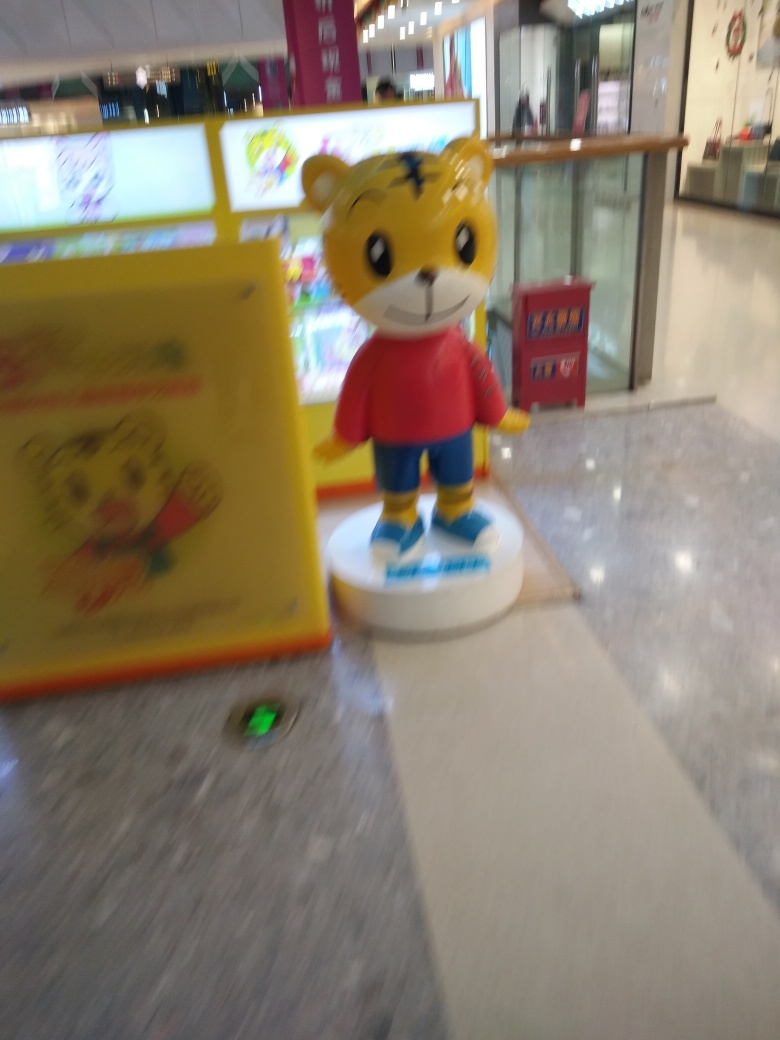What might be the reason for the blurriness in this image? The blurriness is likely due to a combination of camera movement and a slower shutter speed, which didn't freeze the motion of the subject or the holder's hand perfectly. It can also be attributed to a possible low light environment, requiring a longer exposure time, which is harder to hold steady without a tripod or stabilizer. 